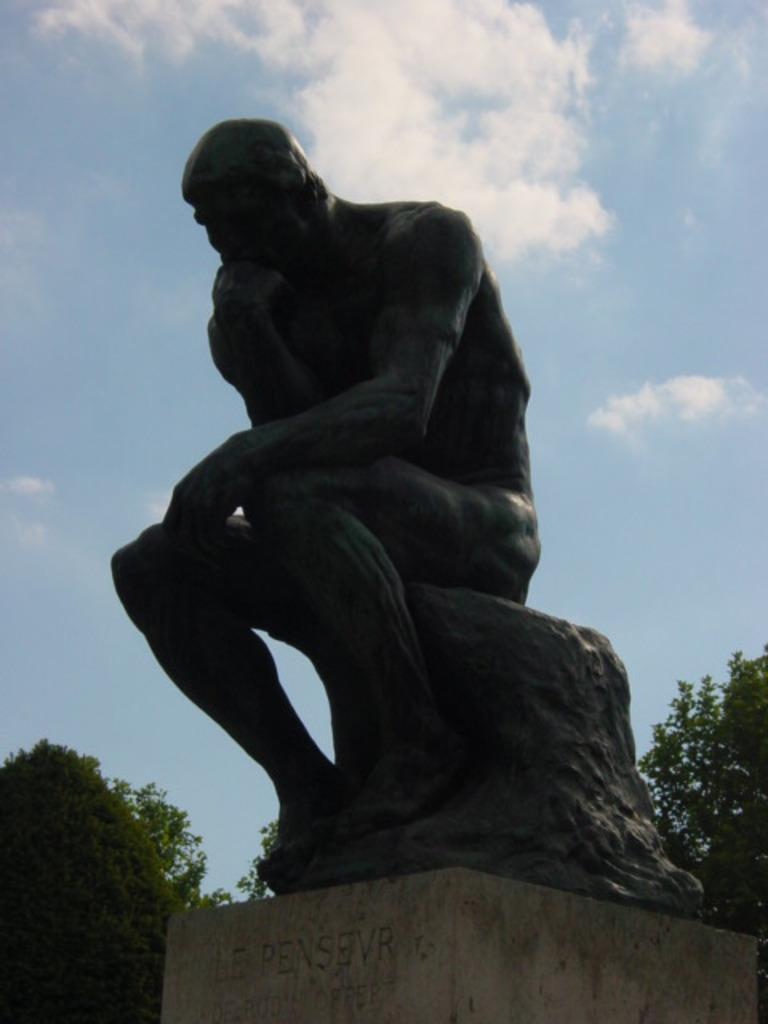What is the main subject in the center of the picture? There is a sculpture in the center of the picture. What can be seen in the background of the picture? There are trees in the background of the picture. How would you describe the weather based on the image? The sky is sunny, which suggests a clear and bright day. What type of locket can be seen hanging from the branches of the trees in the image? There is no locket present in the image; the trees are in the background and do not have any jewelry hanging from them. 